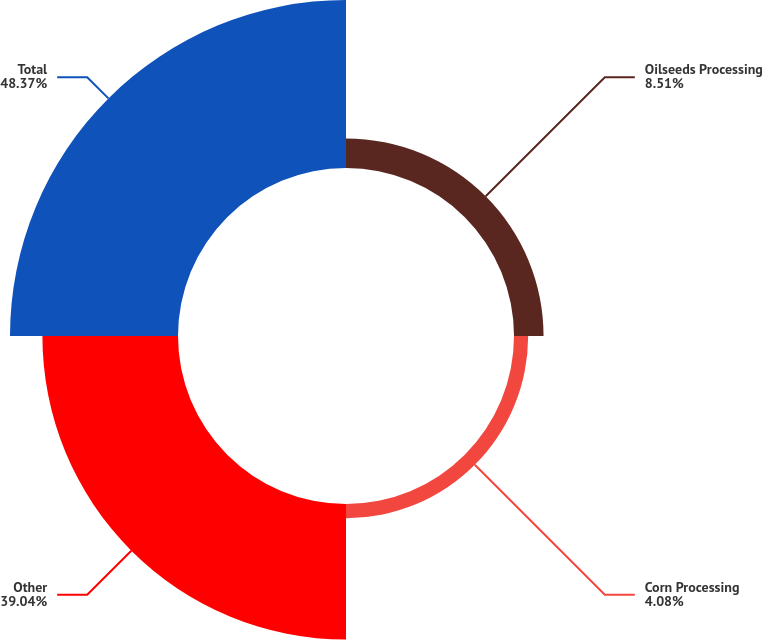Convert chart. <chart><loc_0><loc_0><loc_500><loc_500><pie_chart><fcel>Oilseeds Processing<fcel>Corn Processing<fcel>Other<fcel>Total<nl><fcel>8.51%<fcel>4.08%<fcel>39.04%<fcel>48.37%<nl></chart> 